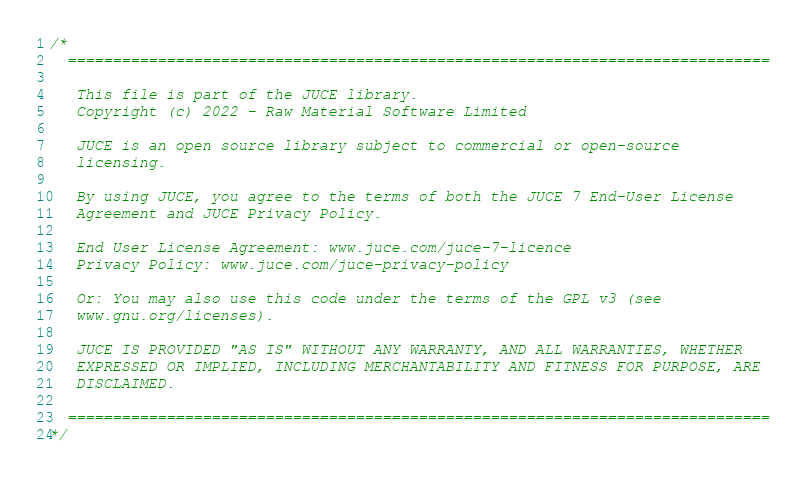<code> <loc_0><loc_0><loc_500><loc_500><_ObjectiveC_>/*
  ==============================================================================

   This file is part of the JUCE library.
   Copyright (c) 2022 - Raw Material Software Limited

   JUCE is an open source library subject to commercial or open-source
   licensing.

   By using JUCE, you agree to the terms of both the JUCE 7 End-User License
   Agreement and JUCE Privacy Policy.

   End User License Agreement: www.juce.com/juce-7-licence
   Privacy Policy: www.juce.com/juce-privacy-policy

   Or: You may also use this code under the terms of the GPL v3 (see
   www.gnu.org/licenses).

   JUCE IS PROVIDED "AS IS" WITHOUT ANY WARRANTY, AND ALL WARRANTIES, WHETHER
   EXPRESSED OR IMPLIED, INCLUDING MERCHANTABILITY AND FITNESS FOR PURPOSE, ARE
   DISCLAIMED.

  ==============================================================================
*/
</code> 